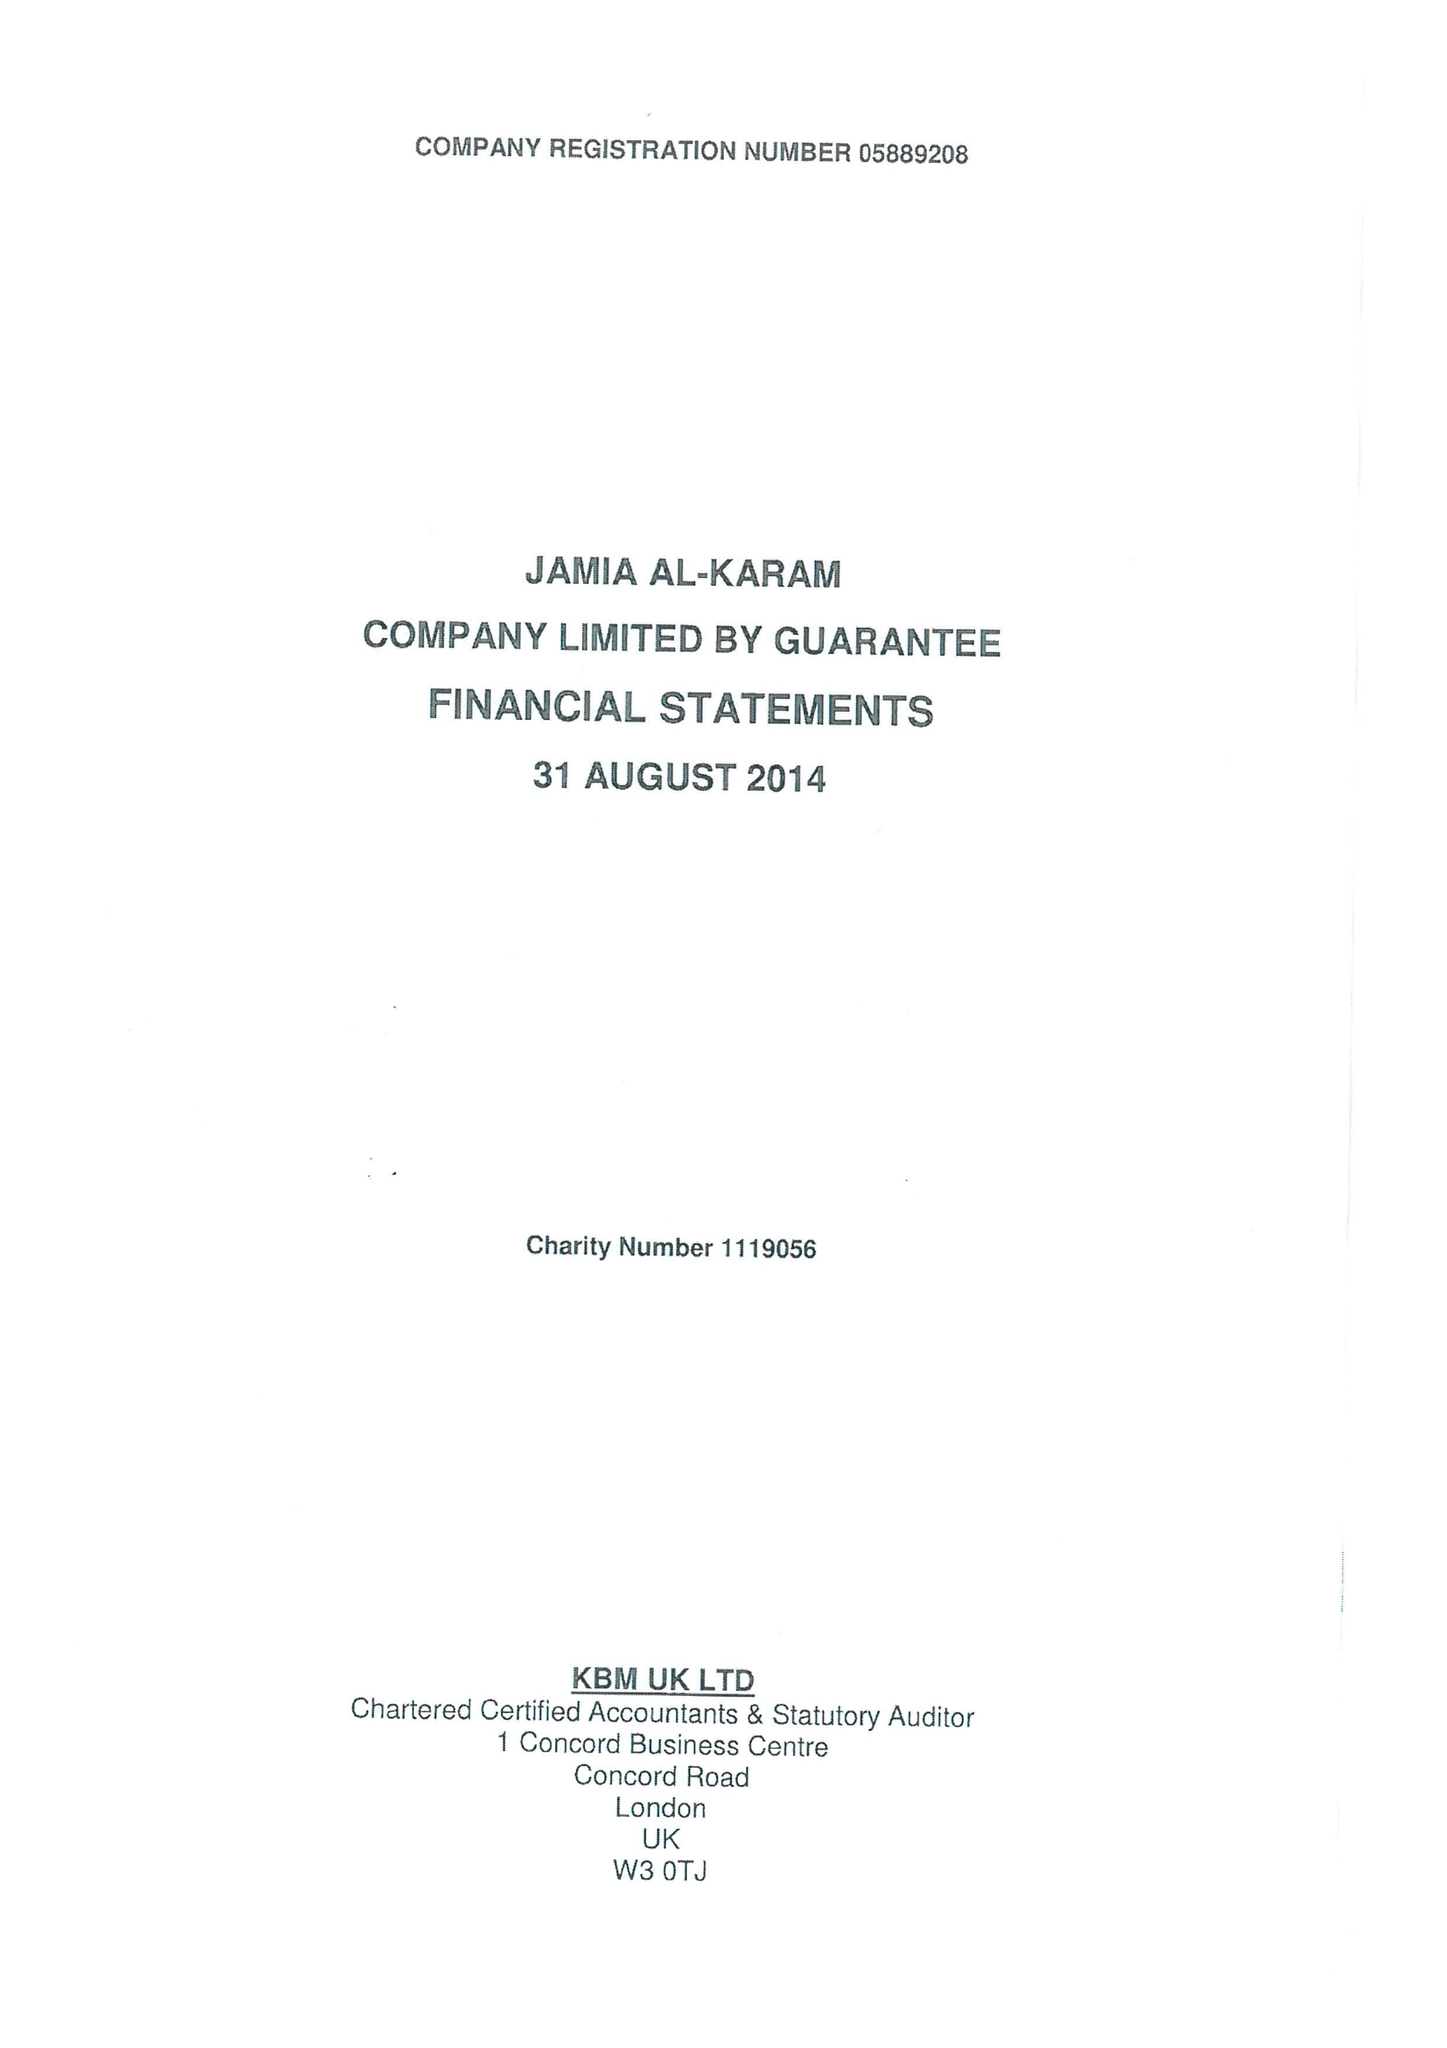What is the value for the report_date?
Answer the question using a single word or phrase. 2014-08-31 